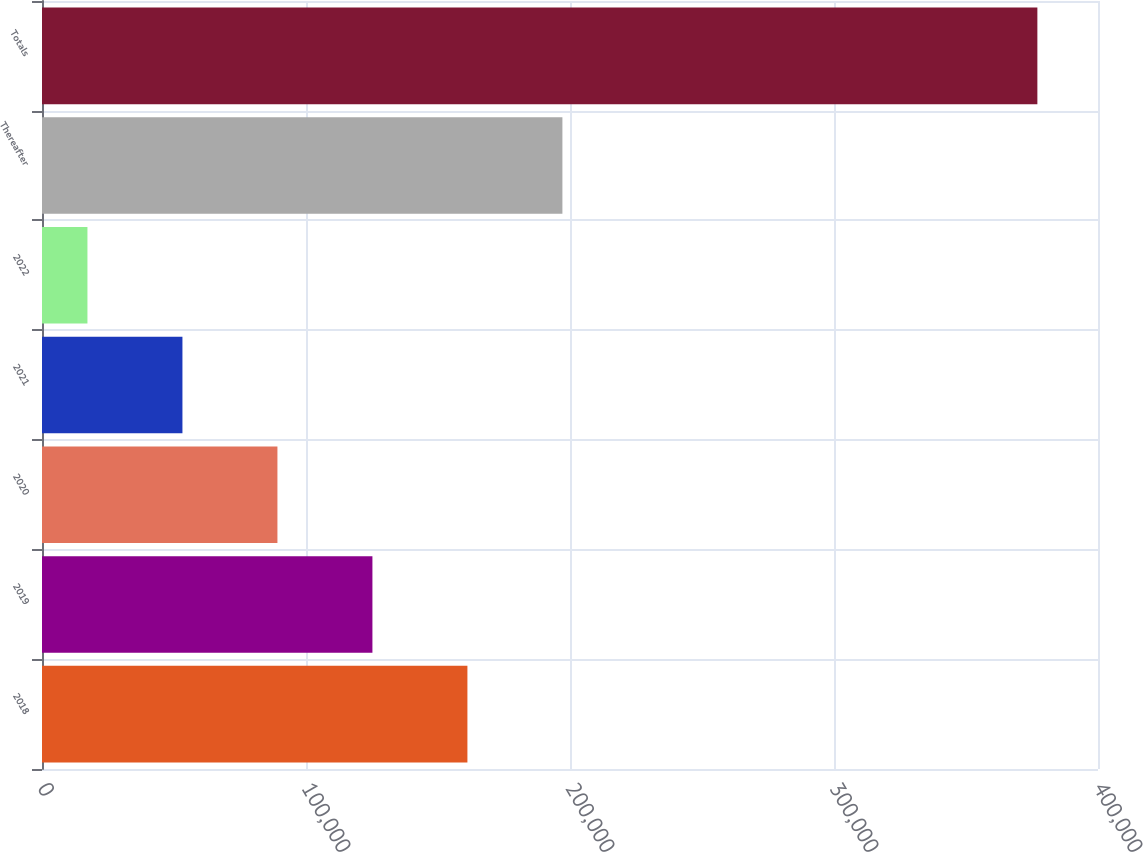<chart> <loc_0><loc_0><loc_500><loc_500><bar_chart><fcel>2018<fcel>2019<fcel>2020<fcel>2021<fcel>2022<fcel>Thereafter<fcel>Totals<nl><fcel>161141<fcel>125159<fcel>89177.2<fcel>53195.1<fcel>17213<fcel>197124<fcel>377034<nl></chart> 